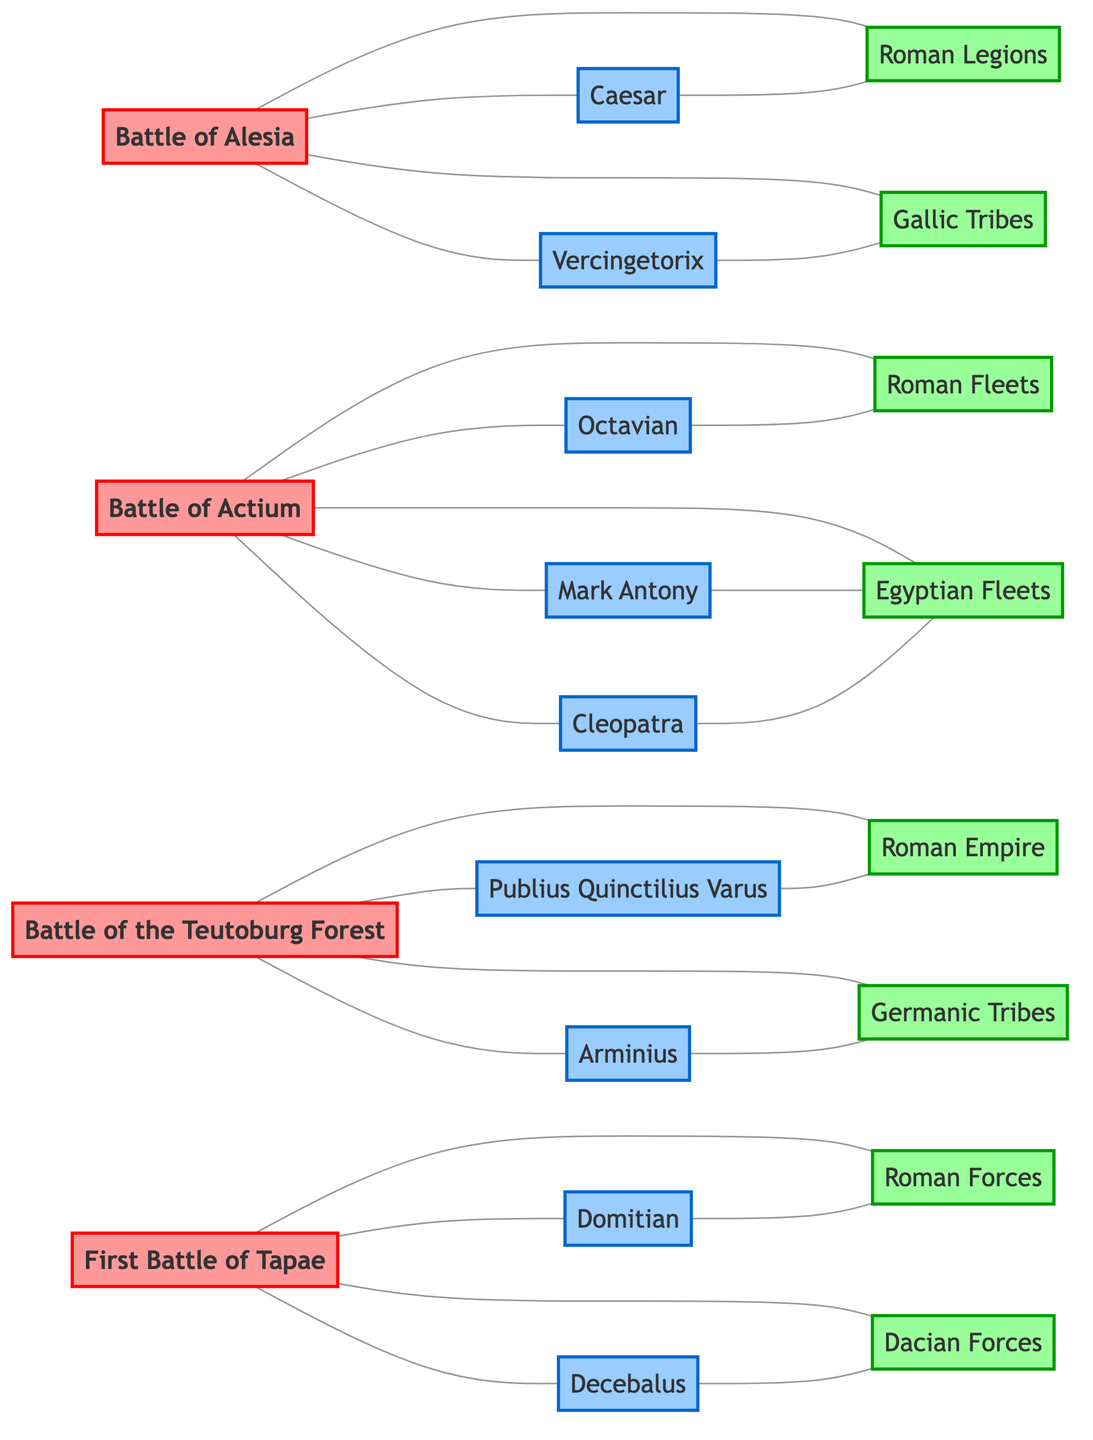What is the total number of battles represented in the diagram? Counting the battle nodes in the diagram, we identify "Battle of Alesia," "Battle of Actium," "Battle of the Teutoburg Forest," and "First Battle of Tapae." There are four battle nodes.
Answer: 4 Who commanded the Battle of Alesia? The edge connecting "Battle of Alesia" to "Caesar" indicates that he commanded this battle.
Answer: Caesar Which forces fought in the Battle of Actium? The diagram shows two forces connected to "Battle of Actium," namely "Roman Fleets" and "Egyptian Fleets." Therefore, both fought in this battle.
Answer: Roman Fleets, Egyptian Fleets Who led the Gallic Tribes during the Battle of Alesia? The edge between "Vercingetorix" and "Gallic Tribes" shows that Vercingetorix led this group.
Answer: Vercingetorix Which leader is connected to the Roman Forces in the First Battle of Tapae? The edge indicates that "Domitian" is connected to "Roman Forces" in the context of the First Battle of Tapae since he is also labeled as commanding the battle.
Answer: Domitian What can be said about the relationship between Octavian and Roman Fleets? The edge indicates a direct relationship where "Octavian" is the leader of "Roman Fleets" during the Battle of Actium; thus, he is connected through leading forces.
Answer: Led How many leaders commanded or co-led in the Battle of Actium? There are three leaders ("Octavian," "Mark Antony," and "Cleopatra") connected to "Battle of Actium," which means three leaders were involved in commanding or co-leading.
Answer: 3 Identify the Germanic leader in the Battle of the Teutoburg Forest. The connection indicates that "Arminius" is the leader of the "Germanic Tribes" during the Battle of the Teutoburg Forest.
Answer: Arminius Which battle involved the Dacian Forces? "Dacian Forces" is directly linked to "First Battle of Tapae," indicating their involvement in this specific battle.
Answer: First Battle of Tapae Is there a direct relationship between Vercingetorix and the Roman Legions in the diagram? The connections show that "Vercingetorix" is linked to "Gallic Tribes" but does not have a direct connection to "Roman Legions." Thus, there is no relationship between them as indicated here.
Answer: No 